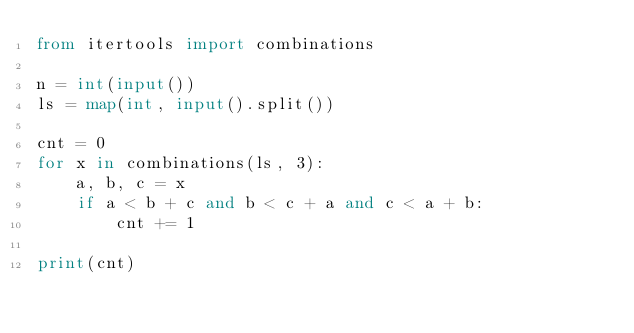Convert code to text. <code><loc_0><loc_0><loc_500><loc_500><_Python_>from itertools import combinations

n = int(input())
ls = map(int, input().split())

cnt = 0
for x in combinations(ls, 3):
    a, b, c = x
    if a < b + c and b < c + a and c < a + b:
        cnt += 1

print(cnt)
</code> 